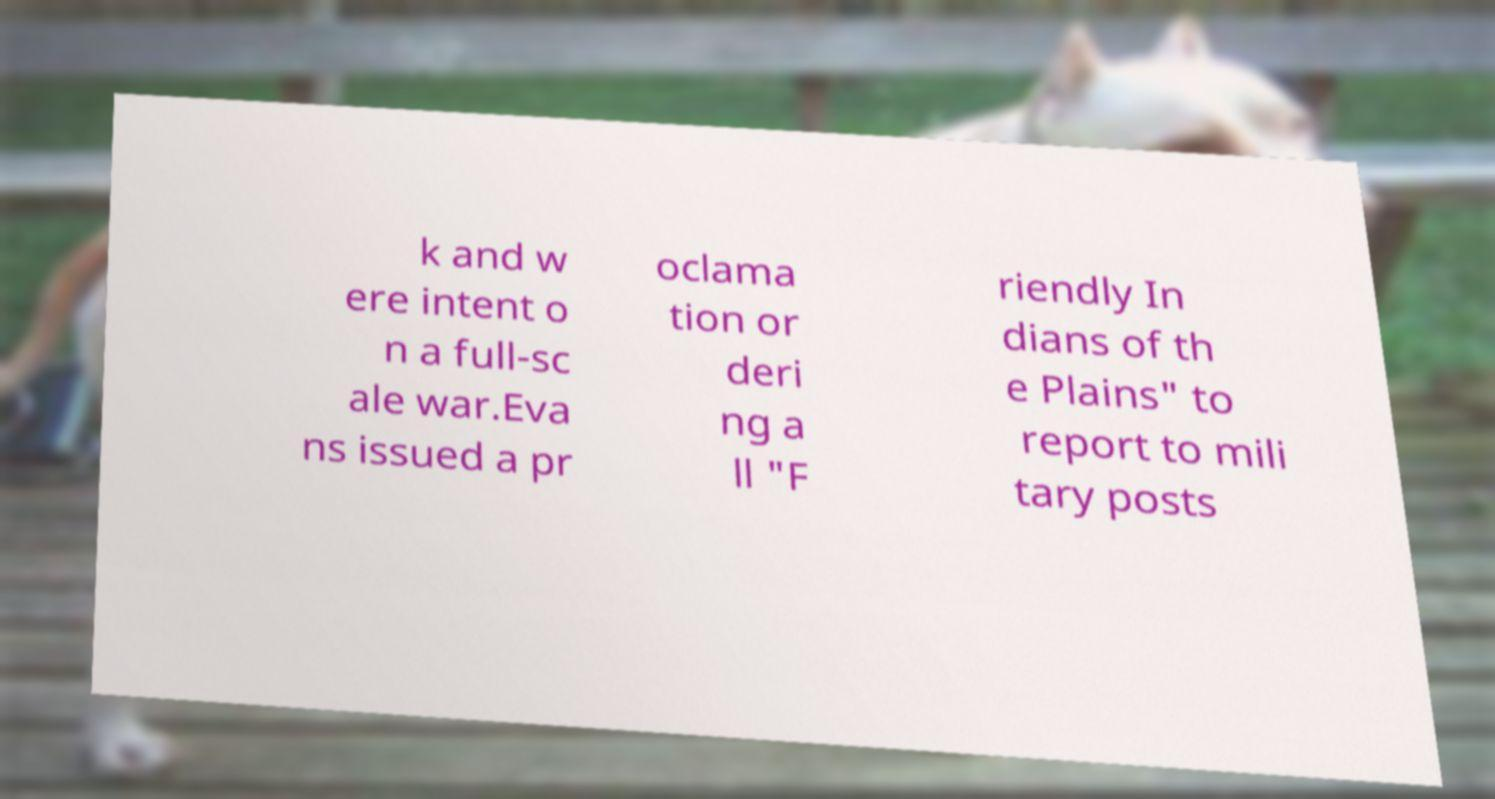Could you extract and type out the text from this image? k and w ere intent o n a full-sc ale war.Eva ns issued a pr oclama tion or deri ng a ll "F riendly In dians of th e Plains" to report to mili tary posts 